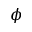Convert formula to latex. <formula><loc_0><loc_0><loc_500><loc_500>\phi</formula> 